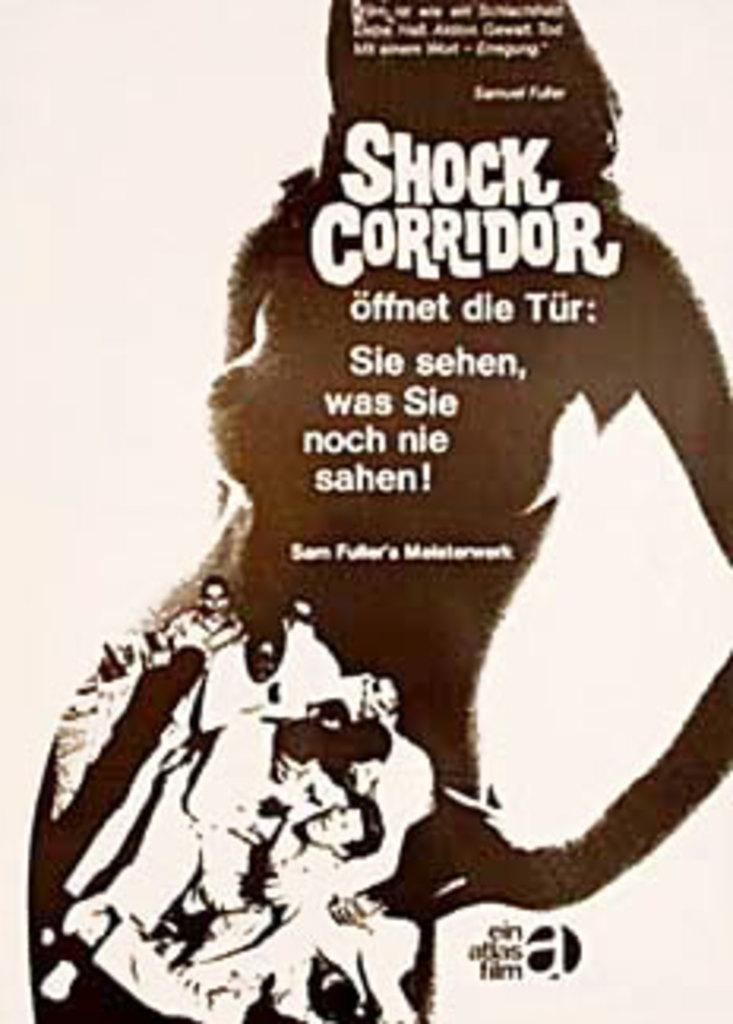What is present on the poster in the image? There is a poster in the image, and it features a person. What else can be seen on the poster besides the person? There is text on the poster. What type of hot beverage is the person holding in the image? There is no hot beverage present in the image; the poster only features a person and text. What does the person's nose look like in the image? There is no nose present in the image, as it is a poster featuring a person and not an actual photograph or illustration of a person. 